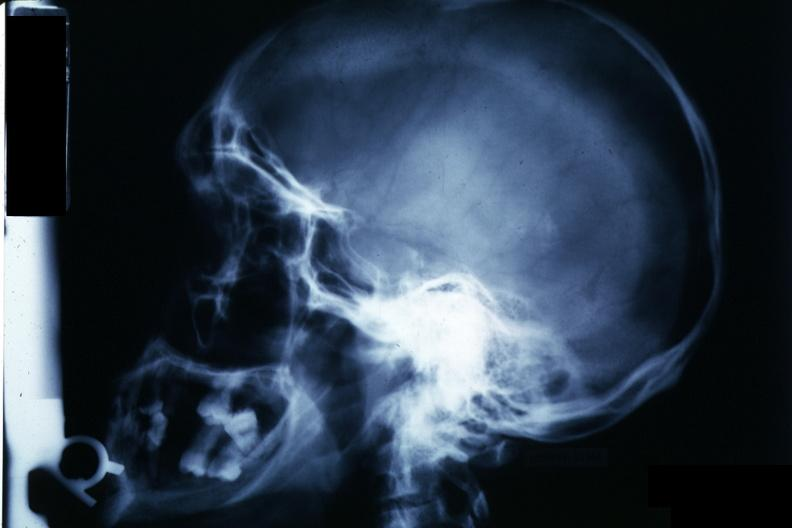what is present?
Answer the question using a single word or phrase. Endocrine 